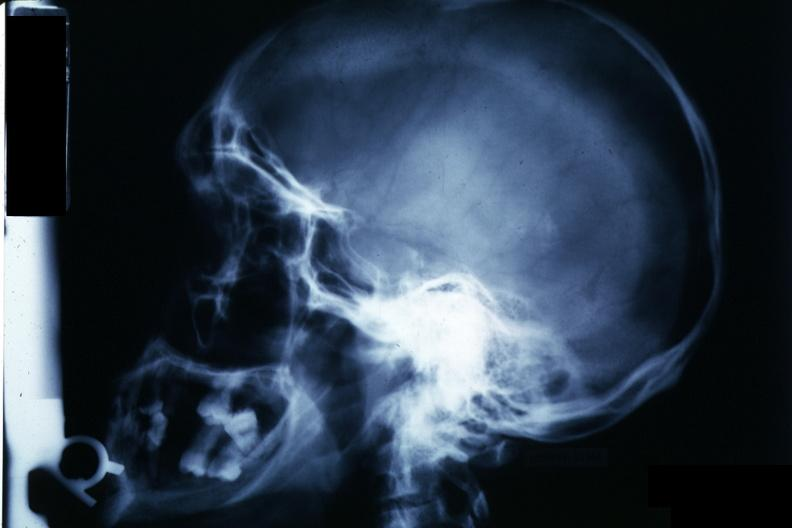what is present?
Answer the question using a single word or phrase. Endocrine 